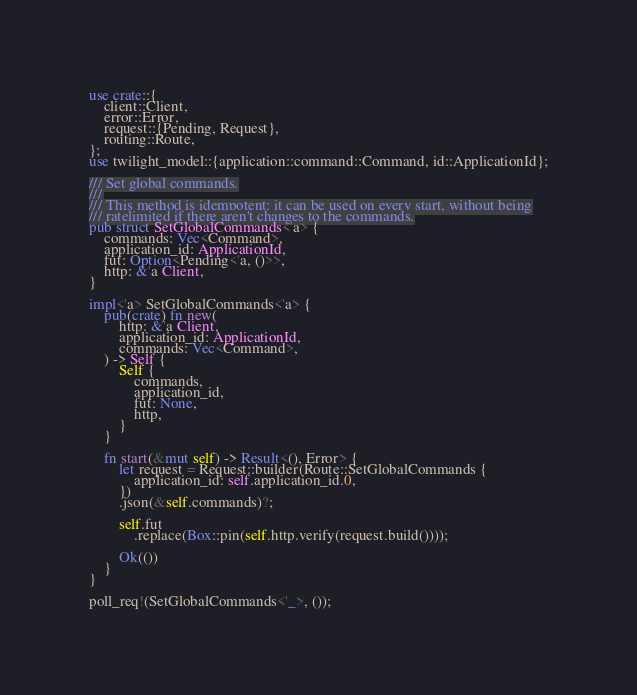Convert code to text. <code><loc_0><loc_0><loc_500><loc_500><_Rust_>use crate::{
    client::Client,
    error::Error,
    request::{Pending, Request},
    routing::Route,
};
use twilight_model::{application::command::Command, id::ApplicationId};

/// Set global commands.
///
/// This method is idempotent: it can be used on every start, without being
/// ratelimited if there aren't changes to the commands.
pub struct SetGlobalCommands<'a> {
    commands: Vec<Command>,
    application_id: ApplicationId,
    fut: Option<Pending<'a, ()>>,
    http: &'a Client,
}

impl<'a> SetGlobalCommands<'a> {
    pub(crate) fn new(
        http: &'a Client,
        application_id: ApplicationId,
        commands: Vec<Command>,
    ) -> Self {
        Self {
            commands,
            application_id,
            fut: None,
            http,
        }
    }

    fn start(&mut self) -> Result<(), Error> {
        let request = Request::builder(Route::SetGlobalCommands {
            application_id: self.application_id.0,
        })
        .json(&self.commands)?;

        self.fut
            .replace(Box::pin(self.http.verify(request.build())));

        Ok(())
    }
}

poll_req!(SetGlobalCommands<'_>, ());
</code> 